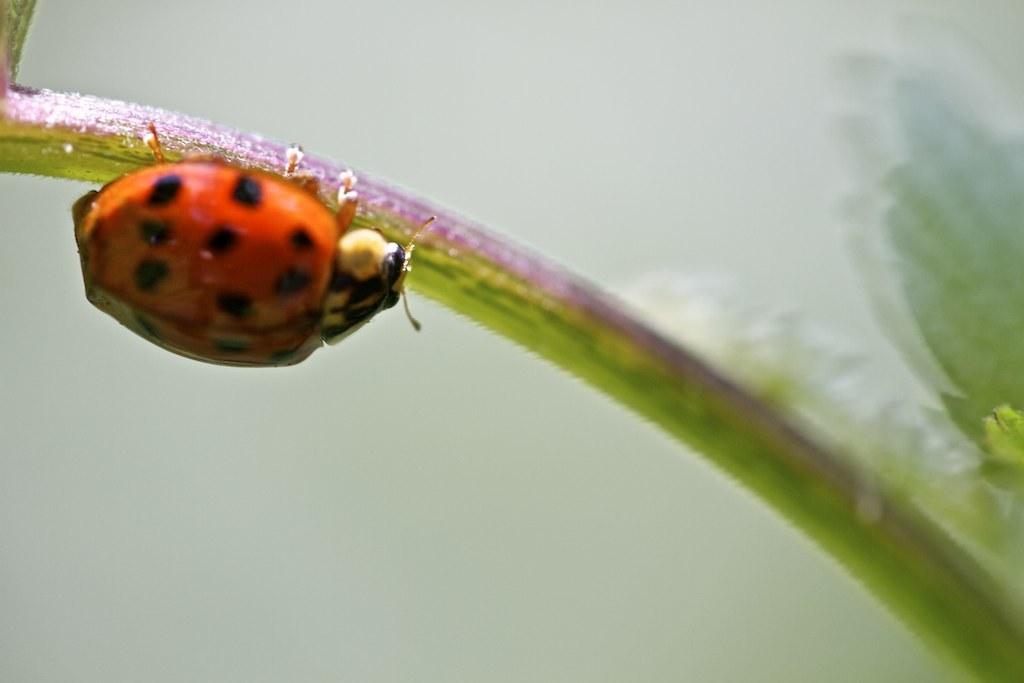What is present on the stem in the image? There is a bug on the stem in the image. On which side of the image is the bug located? The bug is on the left side of the image. What type of education does the group of workers in the image have? There is no group of workers or reference to education in the image; it only features a bug on a stem. 